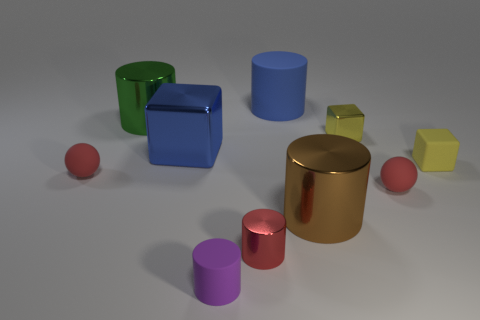Subtract 1 cubes. How many cubes are left? 2 Subtract all large metal cylinders. How many cylinders are left? 3 Subtract all red cylinders. How many cylinders are left? 4 Subtract all brown cylinders. Subtract all green cubes. How many cylinders are left? 4 Subtract all balls. How many objects are left? 8 Subtract all tiny matte objects. Subtract all big blue things. How many objects are left? 4 Add 3 large green metal cylinders. How many large green metal cylinders are left? 4 Add 10 tiny green cylinders. How many tiny green cylinders exist? 10 Subtract 1 blue cylinders. How many objects are left? 9 